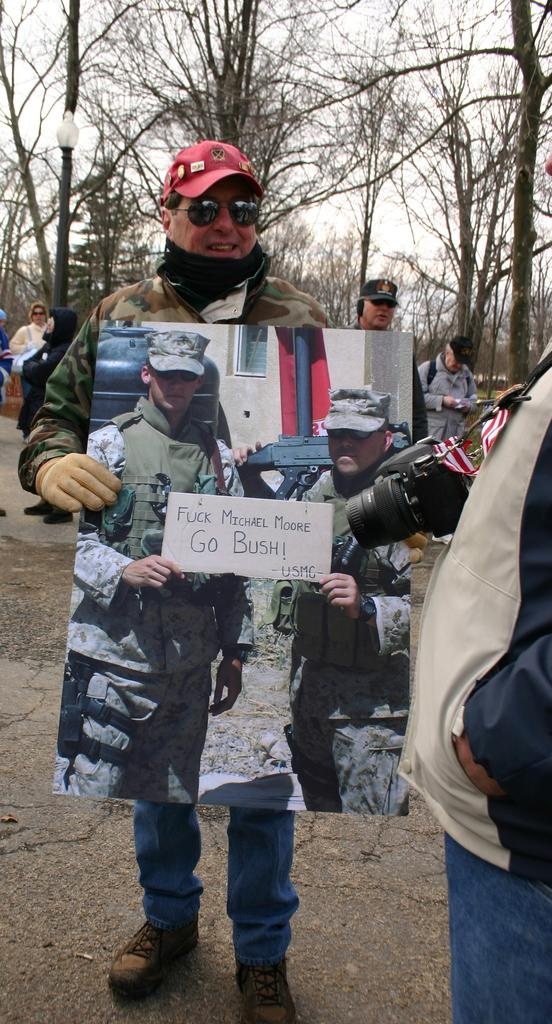What is the man in the image doing? The man is standing in the image. What is the man wearing? The man is wearing a coat and a red color cap. What is the man holding in the image? The man is holding a picture. What can be seen in the picture? The picture contains two men. What is visible in the background of the image? There are trees visible in the background of the image. How many horses are present in the image? There are no horses present in the image. What question is the man asking in the image? The man is not asking a question in the image; he is holding a picture. 